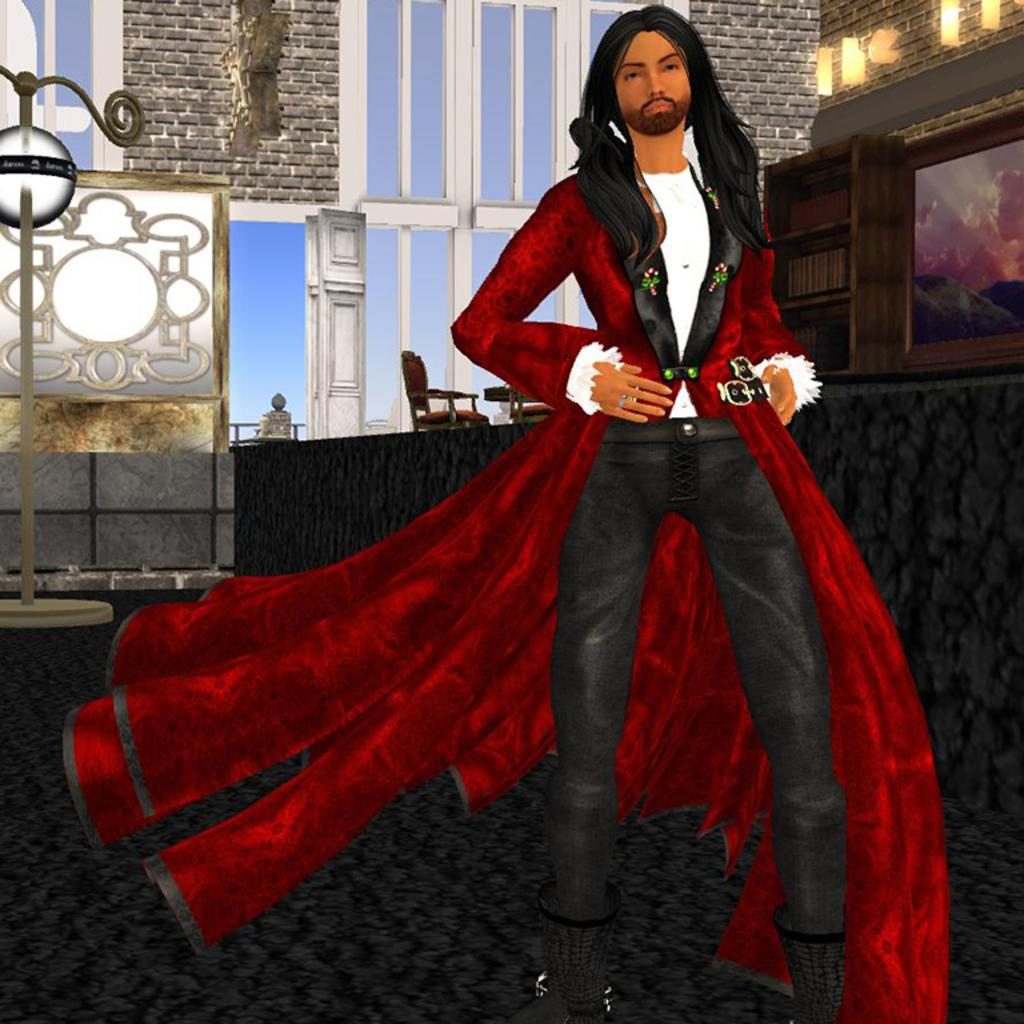What is the main subject of the image? There is a person standing in the image. What can be seen in the background of the image? There are glass windows, a door, a light pole, a chair, a rack, lights, and a picture in the background. Can you describe the door in the background? The door is located in the background, but no specific details about the door are provided in the facts. What type of objects are present on the rack in the background? The facts do not specify what type of objects are present on the rack in the background. What color are the cherries on the person's skin in the image? There are no cherries or mention of skin color in the image, so this question cannot be answered. 